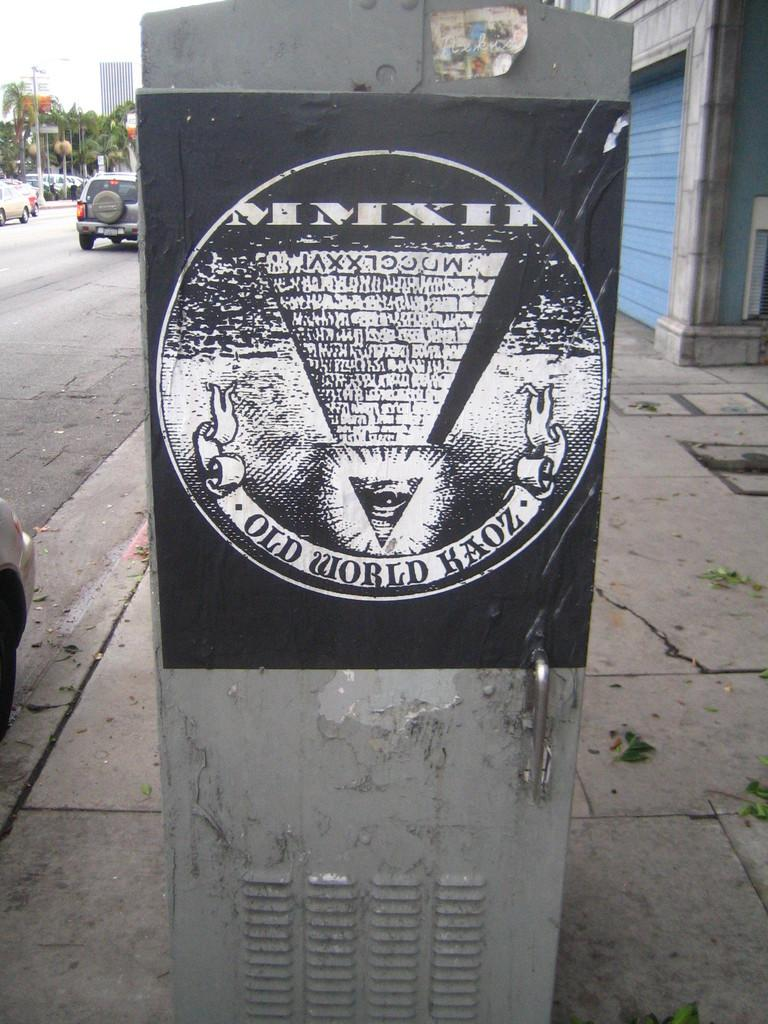<image>
Present a compact description of the photo's key features. Black sign on a silver object which says "Old World Kaoz" on it. 